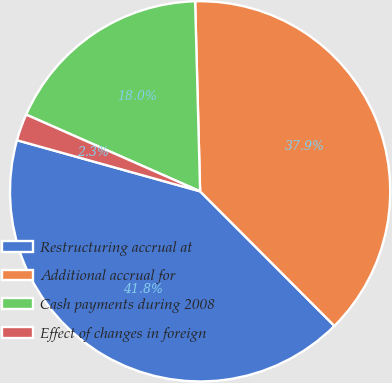Convert chart to OTSL. <chart><loc_0><loc_0><loc_500><loc_500><pie_chart><fcel>Restructuring accrual at<fcel>Additional accrual for<fcel>Cash payments during 2008<fcel>Effect of changes in foreign<nl><fcel>41.81%<fcel>37.93%<fcel>17.97%<fcel>2.28%<nl></chart> 